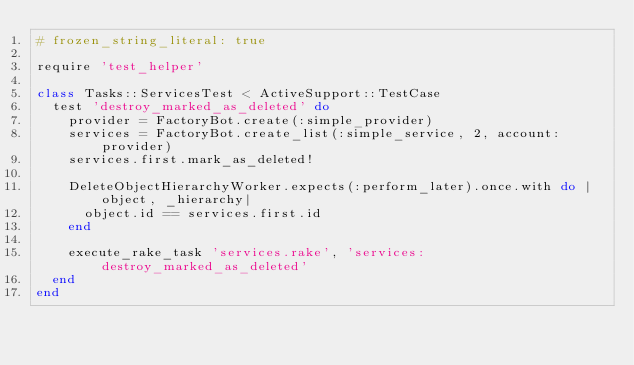<code> <loc_0><loc_0><loc_500><loc_500><_Ruby_># frozen_string_literal: true

require 'test_helper'

class Tasks::ServicesTest < ActiveSupport::TestCase
  test 'destroy_marked_as_deleted' do
    provider = FactoryBot.create(:simple_provider)
    services = FactoryBot.create_list(:simple_service, 2, account: provider)
    services.first.mark_as_deleted!

    DeleteObjectHierarchyWorker.expects(:perform_later).once.with do |object, _hierarchy|
      object.id == services.first.id
    end

    execute_rake_task 'services.rake', 'services:destroy_marked_as_deleted'
  end
end
</code> 